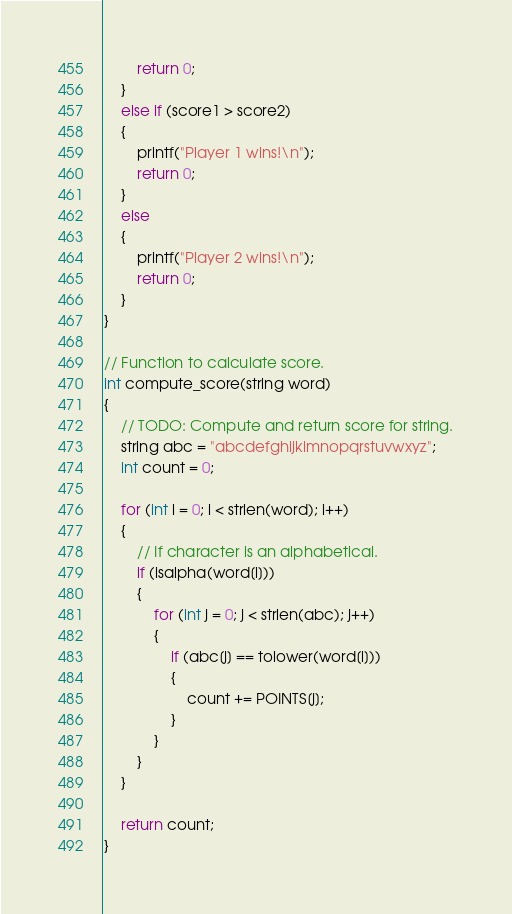<code> <loc_0><loc_0><loc_500><loc_500><_C_>        return 0;
    }
    else if (score1 > score2)
    {
        printf("Player 1 wins!\n");
        return 0;
    }
    else
    {
        printf("Player 2 wins!\n");
        return 0;
    }
}

// Function to calculate score.
int compute_score(string word)
{
    // TODO: Compute and return score for string.
    string abc = "abcdefghijklmnopqrstuvwxyz";
    int count = 0;

    for (int i = 0; i < strlen(word); i++)
    {
        // If character is an alphabetical.
        if (isalpha(word[i]))
        {
            for (int j = 0; j < strlen(abc); j++)
            {
                if (abc[j] == tolower(word[i]))
                {
                    count += POINTS[j];
                }
            }
        }
    }

    return count;
}
</code> 